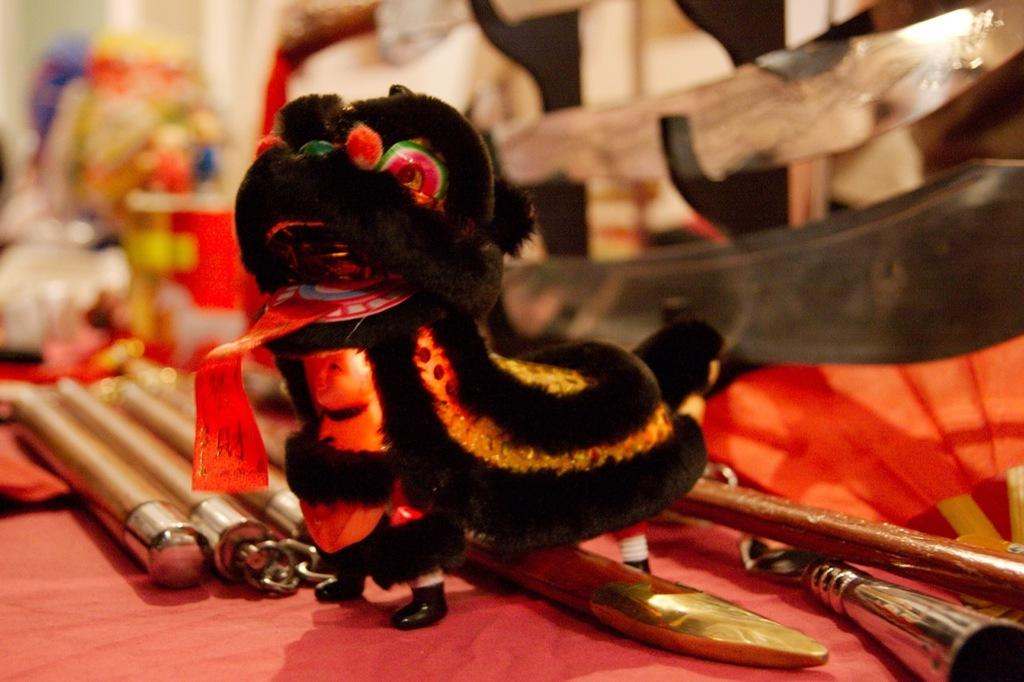What can be seen in the image that resembles a toy? There is a toy in the image. What is the toy placed on or near? There are items on an object in the image, which the toy may be placed on or near. What can be observed in the background of the image? There are blurred objects in the background of the image. Is the toy being driven by rain in the image? There is no rain or driving present in the image, and therefore the toy cannot be driven by rain. 